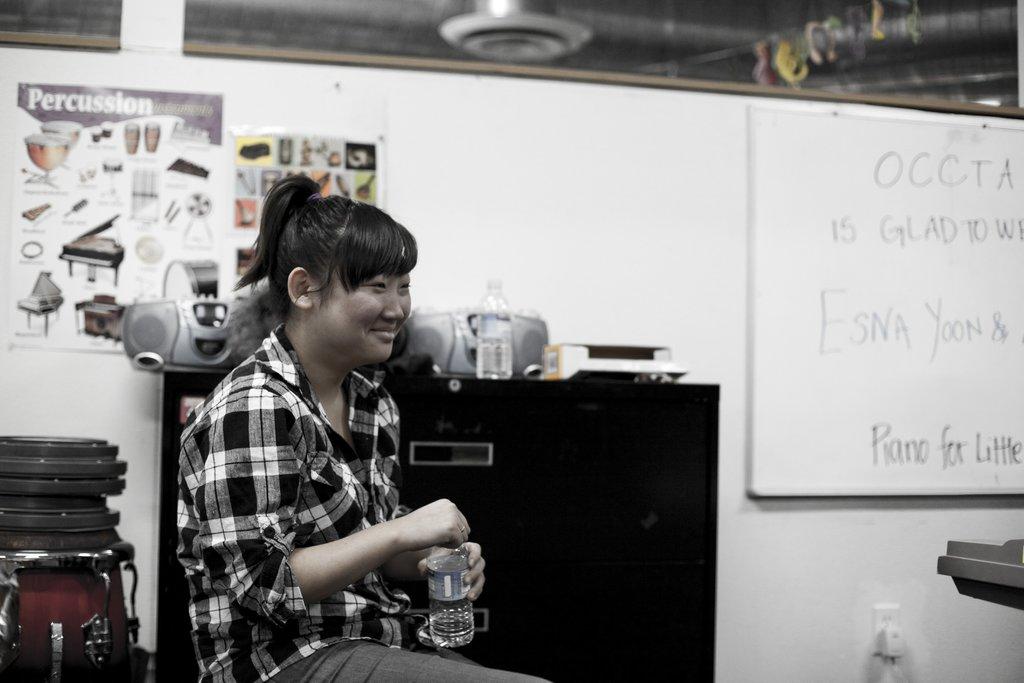What instrument is mentioned on the white board?
Offer a terse response. Piano. 